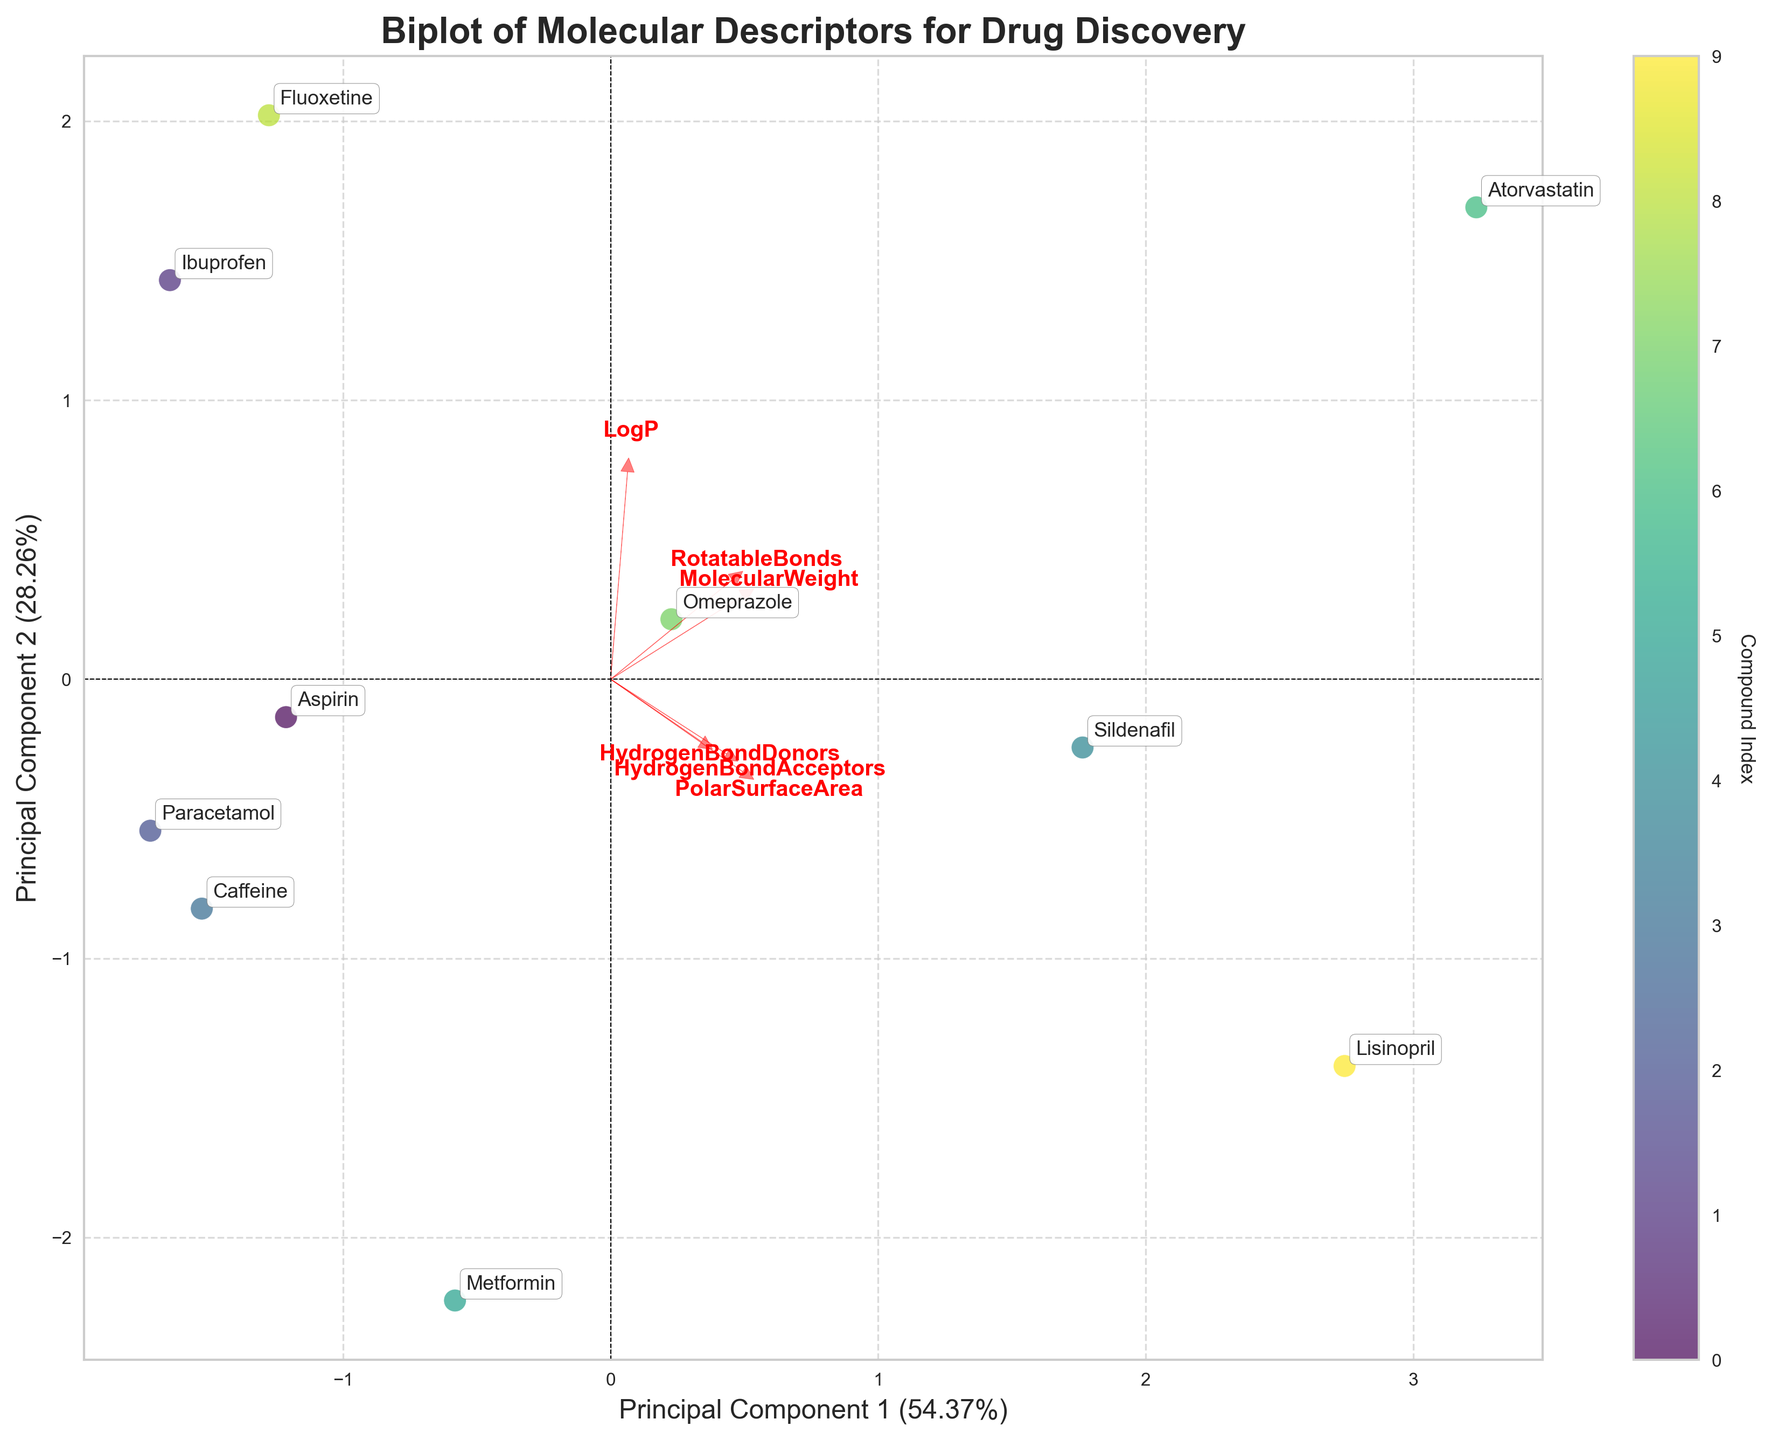What's the title of the biplot? The title of the biplot is usually displayed at the top center of the figure.
Answer: Biplot of Molecular Descriptors for Drug Discovery How many compounds are visualized in the biplot? The number of unique labels or points representing compounds in the plot gives this information. Count the labels or points.
Answer: 10 Which principal component explains the most variance? Look at the axis labels to see the percentage of variance explained by each principal component. Principal Component 1 (PC1) or Principal Component 2 (PC2).
Answer: Principal Component 1 Which compound is nearest to the origin (0,0) in the biplot? Identify the point (compound label) closest to the origin by visually inspecting the plot.
Answer: Caffeine Which two drugs have similar physicochemical properties based on their positions in the biplot? Look for two compounds that are plotted close together on both the x and y axes.
Answer: Omeprazole and Fluoxetine Which feature vector has the longest arrow in the biplot? The feature with the longest red arrow pointing outward from the origin in the plot.
Answer: PolarSurfaceArea Is there any compound with a negative PC1 value and a positive PC2 value? Check each compound's position along the x-axis (PC1) and y-axis (PC2). If any compound falls in the quadrant where x is negative and y is positive, then it fulfills this condition.
Answer: Yes Which compound is most affected by the feature 'PolarSurfaceArea' according to the biplot? Identify which compound lies farthest along the direction of the PolarSurfaceArea vector.
Answer: Lisinopril What inference can be made about the 'RotatableBonds' feature based on the biplot? Observe the direction and length of the 'RotatableBonds' arrow, and see how much it contributes to separating the compounds along the principal components.
Answer: It significantly contributes to the spread along PC1 Which has higher LogP, Fluoxetine or Aspirin? Locate positions of Fluoxetine and Aspirin on the biplot and check their relative positions along the direction of the LogP vector.
Answer: Fluoxetine 